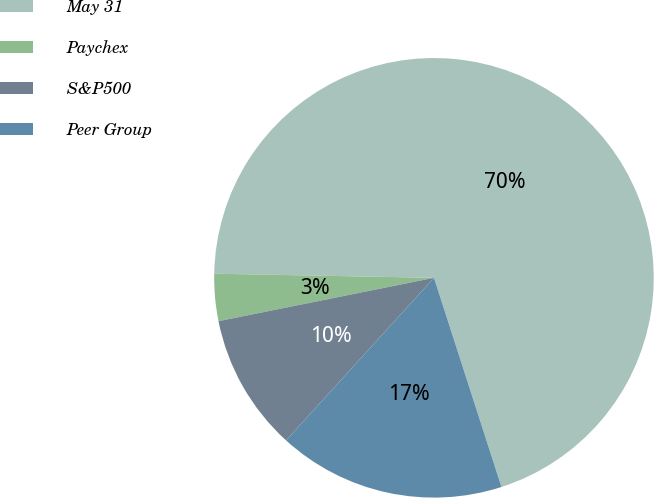<chart> <loc_0><loc_0><loc_500><loc_500><pie_chart><fcel>May 31<fcel>Paychex<fcel>S&P500<fcel>Peer Group<nl><fcel>69.73%<fcel>3.46%<fcel>10.09%<fcel>16.72%<nl></chart> 